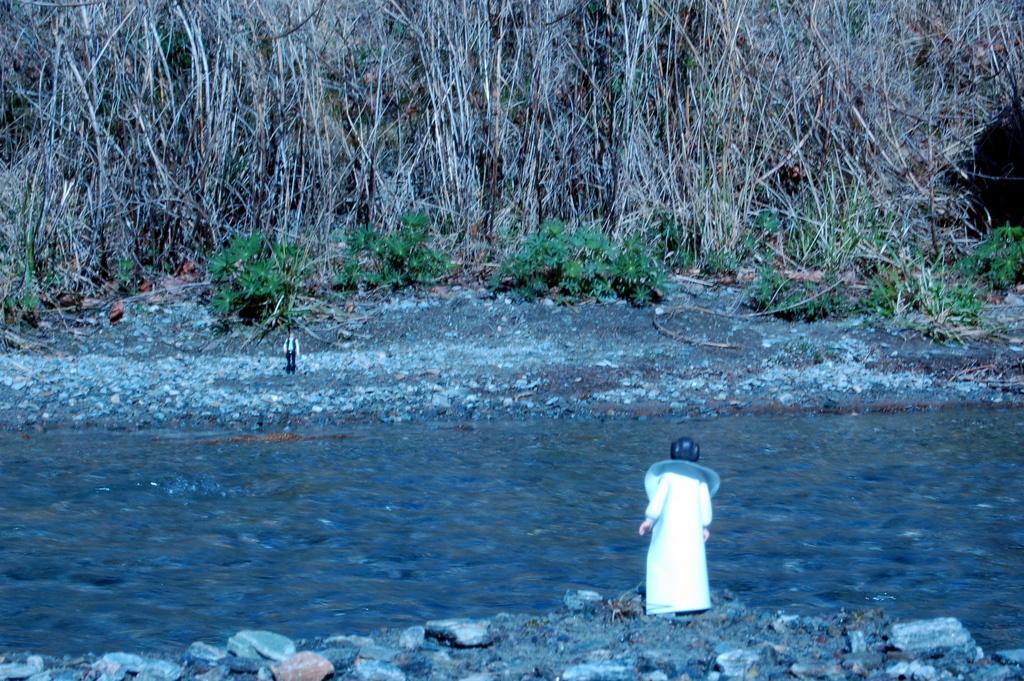Could you give a brief overview of what you see in this image? In this image we can see a river. On the sides of the river there are rocks. Also there two persons on the sides of the river. In the background there are trees and plants. 